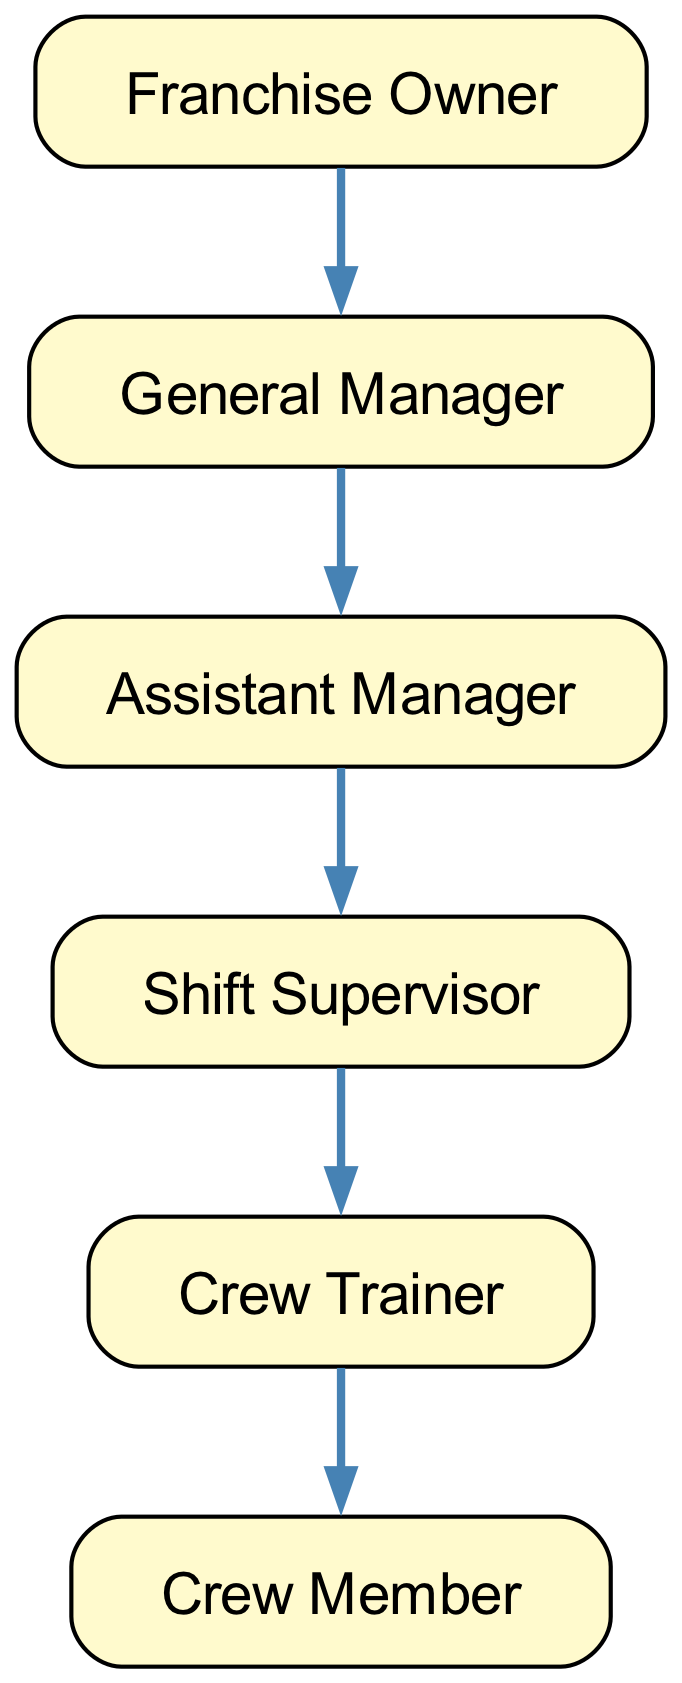What is the highest position in the hierarchy? The hierarchy starts with the Franchise Owner at the topmost position without any nodes above it, therefore it is the highest position in the diagram.
Answer: Franchise Owner How many levels are there in this management structure? The hierarchy comprises six distinct roles arranged in five levels (Franchise Owner as level 1, then General Manager level 2, Assistant Manager level 3, Shift Supervisor level 4, Crew Trainer level 5, and Crew Member level 6). Counting these gives a total of five levels in the structure.
Answer: 5 Who reports directly to the General Manager? The General Manager has an Assistant Manager directly below them in the hierarchy shown, indicating that the Assistant Manager is the direct report.
Answer: Assistant Manager What is the position of Crew Trainer in relation to Crew Member? The hierarchy shows a direct link from Crew Trainer to Crew Member, indicating that the Crew Member reports to and is under the supervision of the Crew Trainer in the structure.
Answer: Crew Member How many edges are present in this diagram? The structure has five edges connecting the six nodes, which indicates the direct reporting relationships among the roles. Each edge represents one reporting line, and thus when counted, they total up to five.
Answer: 5 Which role is the first level of the hierarchy? The diagram initiates with the Franchise Owner at the first level, and it is positioned at the top, indicating its significance as the first role in the organization.
Answer: Franchise Owner What role is directly two levels below the Franchise Owner? If one moves two levels down from the Franchise Owner, you'll first reach the General Manager, and from there, the next level down is the Assistant Manager, which is two levels below the Franchise Owner.
Answer: Assistant Manager Which role acts as a supervisor to Crew Members? There is a direct relationship indicating that the Crew Trainer supervises Crew Members, meaning that the Crew Trainer is responsible for overseeing the Crew Members' activities and training.
Answer: Crew Trainer What position is directly above Shift Supervisor? Looking at the positioning within the hierarchy, the position that is directly above the Shift Supervisor is the Assistant Manager, indicating the chain of command.
Answer: Assistant Manager 